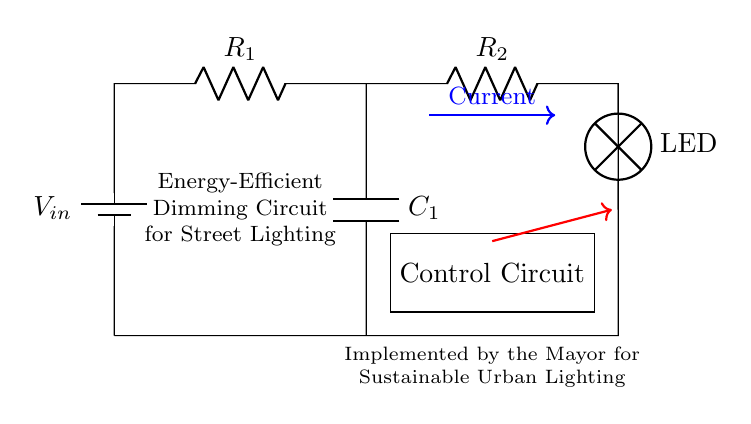What type of circuit is depicted in the diagram? The circuit shows a resistor-capacitor configuration suitable for dimming applications.
Answer: Resistor-capacitor What is the function of the capacitor in this circuit? The capacitor in this circuit helps in smoothing the voltage and storing energy, allowing for a gradual dimming effect of the street light.
Answer: Smoothing voltage What does the control circuit do? The control circuit modulates the current flowing to the LED, adjusting its brightness based on predetermined conditions.
Answer: Modulate current How many resistors are present in the circuit? There are two resistors connected in series in the circuit pathway.
Answer: Two What could be the effect of increasing the value of R1? Increasing R1 will reduce the current passing through the circuit, leading to dimmer LED brightness.
Answer: Dimmer LED How is the energy stored in the circuit during operation? Energy is stored in the capacitor when it charges and is released to the LED as it discharges, contributing to the dimming effect.
Answer: Stored in the capacitor What is the primary benefit of using an energy-efficient dimming circuit for street lighting? The primary benefit is reduced energy consumption while maintaining adequate illumination, contributing to sustainability goals.
Answer: Reduced energy consumption 